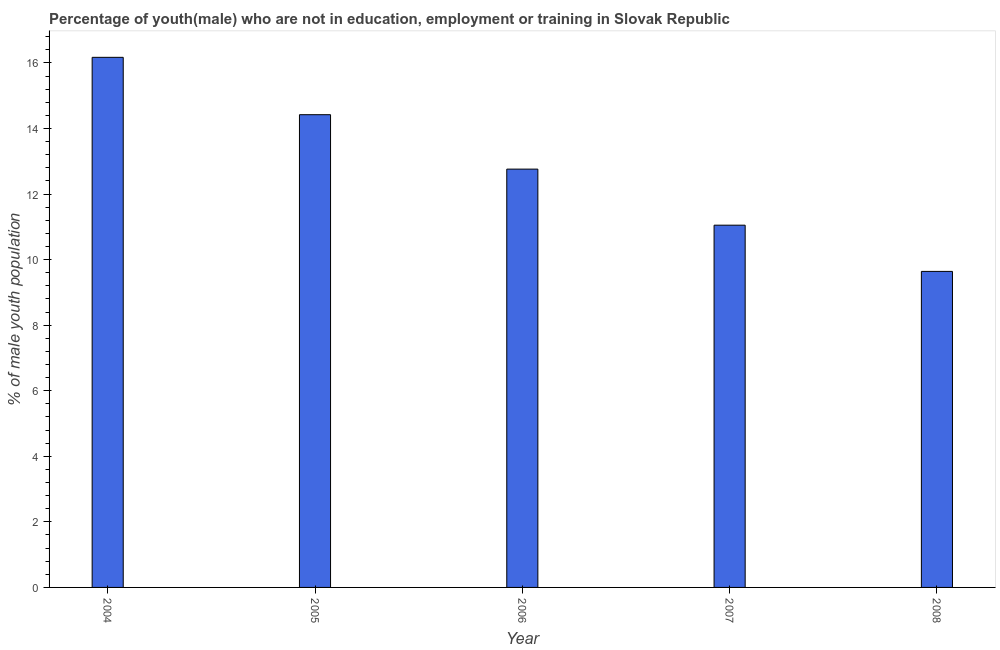Does the graph contain any zero values?
Ensure brevity in your answer.  No. What is the title of the graph?
Give a very brief answer. Percentage of youth(male) who are not in education, employment or training in Slovak Republic. What is the label or title of the Y-axis?
Provide a succinct answer. % of male youth population. What is the unemployed male youth population in 2006?
Make the answer very short. 12.76. Across all years, what is the maximum unemployed male youth population?
Your answer should be very brief. 16.17. Across all years, what is the minimum unemployed male youth population?
Provide a succinct answer. 9.64. In which year was the unemployed male youth population maximum?
Make the answer very short. 2004. What is the sum of the unemployed male youth population?
Your response must be concise. 64.04. What is the difference between the unemployed male youth population in 2004 and 2007?
Offer a terse response. 5.12. What is the average unemployed male youth population per year?
Make the answer very short. 12.81. What is the median unemployed male youth population?
Your answer should be compact. 12.76. Do a majority of the years between 2008 and 2005 (inclusive) have unemployed male youth population greater than 14.8 %?
Give a very brief answer. Yes. What is the ratio of the unemployed male youth population in 2004 to that in 2008?
Your response must be concise. 1.68. Is the unemployed male youth population in 2005 less than that in 2007?
Keep it short and to the point. No. Is the sum of the unemployed male youth population in 2005 and 2006 greater than the maximum unemployed male youth population across all years?
Your answer should be very brief. Yes. What is the difference between the highest and the lowest unemployed male youth population?
Keep it short and to the point. 6.53. In how many years, is the unemployed male youth population greater than the average unemployed male youth population taken over all years?
Offer a terse response. 2. Are all the bars in the graph horizontal?
Make the answer very short. No. What is the difference between two consecutive major ticks on the Y-axis?
Provide a succinct answer. 2. What is the % of male youth population in 2004?
Give a very brief answer. 16.17. What is the % of male youth population in 2005?
Your response must be concise. 14.42. What is the % of male youth population in 2006?
Make the answer very short. 12.76. What is the % of male youth population in 2007?
Your answer should be very brief. 11.05. What is the % of male youth population of 2008?
Provide a short and direct response. 9.64. What is the difference between the % of male youth population in 2004 and 2006?
Offer a very short reply. 3.41. What is the difference between the % of male youth population in 2004 and 2007?
Give a very brief answer. 5.12. What is the difference between the % of male youth population in 2004 and 2008?
Make the answer very short. 6.53. What is the difference between the % of male youth population in 2005 and 2006?
Keep it short and to the point. 1.66. What is the difference between the % of male youth population in 2005 and 2007?
Provide a short and direct response. 3.37. What is the difference between the % of male youth population in 2005 and 2008?
Offer a very short reply. 4.78. What is the difference between the % of male youth population in 2006 and 2007?
Keep it short and to the point. 1.71. What is the difference between the % of male youth population in 2006 and 2008?
Offer a very short reply. 3.12. What is the difference between the % of male youth population in 2007 and 2008?
Offer a terse response. 1.41. What is the ratio of the % of male youth population in 2004 to that in 2005?
Provide a succinct answer. 1.12. What is the ratio of the % of male youth population in 2004 to that in 2006?
Offer a very short reply. 1.27. What is the ratio of the % of male youth population in 2004 to that in 2007?
Provide a short and direct response. 1.46. What is the ratio of the % of male youth population in 2004 to that in 2008?
Make the answer very short. 1.68. What is the ratio of the % of male youth population in 2005 to that in 2006?
Make the answer very short. 1.13. What is the ratio of the % of male youth population in 2005 to that in 2007?
Keep it short and to the point. 1.3. What is the ratio of the % of male youth population in 2005 to that in 2008?
Provide a succinct answer. 1.5. What is the ratio of the % of male youth population in 2006 to that in 2007?
Your response must be concise. 1.16. What is the ratio of the % of male youth population in 2006 to that in 2008?
Make the answer very short. 1.32. What is the ratio of the % of male youth population in 2007 to that in 2008?
Offer a terse response. 1.15. 